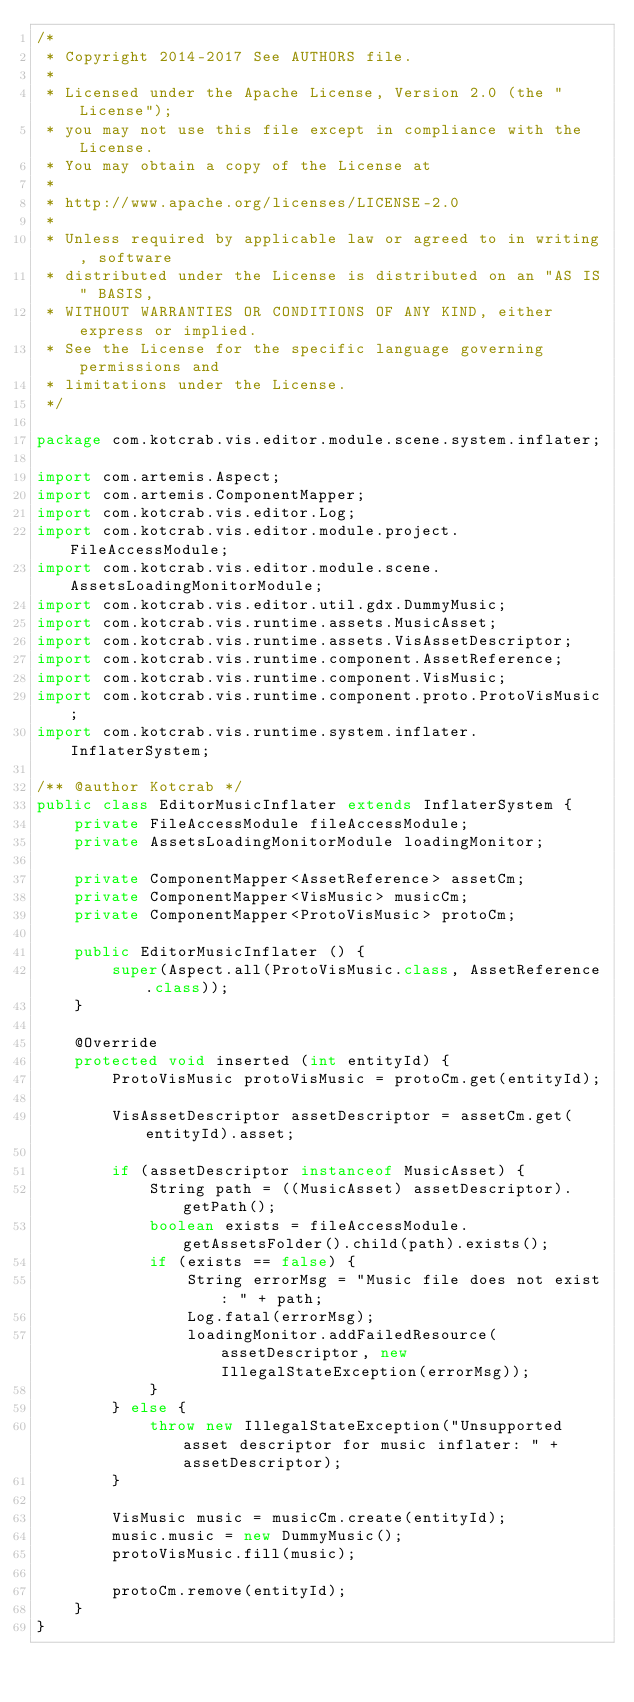<code> <loc_0><loc_0><loc_500><loc_500><_Java_>/*
 * Copyright 2014-2017 See AUTHORS file.
 *
 * Licensed under the Apache License, Version 2.0 (the "License");
 * you may not use this file except in compliance with the License.
 * You may obtain a copy of the License at
 *
 * http://www.apache.org/licenses/LICENSE-2.0
 *
 * Unless required by applicable law or agreed to in writing, software
 * distributed under the License is distributed on an "AS IS" BASIS,
 * WITHOUT WARRANTIES OR CONDITIONS OF ANY KIND, either express or implied.
 * See the License for the specific language governing permissions and
 * limitations under the License.
 */

package com.kotcrab.vis.editor.module.scene.system.inflater;

import com.artemis.Aspect;
import com.artemis.ComponentMapper;
import com.kotcrab.vis.editor.Log;
import com.kotcrab.vis.editor.module.project.FileAccessModule;
import com.kotcrab.vis.editor.module.scene.AssetsLoadingMonitorModule;
import com.kotcrab.vis.editor.util.gdx.DummyMusic;
import com.kotcrab.vis.runtime.assets.MusicAsset;
import com.kotcrab.vis.runtime.assets.VisAssetDescriptor;
import com.kotcrab.vis.runtime.component.AssetReference;
import com.kotcrab.vis.runtime.component.VisMusic;
import com.kotcrab.vis.runtime.component.proto.ProtoVisMusic;
import com.kotcrab.vis.runtime.system.inflater.InflaterSystem;

/** @author Kotcrab */
public class EditorMusicInflater extends InflaterSystem {
	private FileAccessModule fileAccessModule;
	private AssetsLoadingMonitorModule loadingMonitor;

	private ComponentMapper<AssetReference> assetCm;
	private ComponentMapper<VisMusic> musicCm;
	private ComponentMapper<ProtoVisMusic> protoCm;

	public EditorMusicInflater () {
		super(Aspect.all(ProtoVisMusic.class, AssetReference.class));
	}

	@Override
	protected void inserted (int entityId) {
		ProtoVisMusic protoVisMusic = protoCm.get(entityId);

		VisAssetDescriptor assetDescriptor = assetCm.get(entityId).asset;

		if (assetDescriptor instanceof MusicAsset) {
			String path = ((MusicAsset) assetDescriptor).getPath();
			boolean exists = fileAccessModule.getAssetsFolder().child(path).exists();
			if (exists == false) {
				String errorMsg = "Music file does not exist: " + path;
				Log.fatal(errorMsg);
				loadingMonitor.addFailedResource(assetDescriptor, new IllegalStateException(errorMsg));
			}
		} else {
			throw new IllegalStateException("Unsupported asset descriptor for music inflater: " + assetDescriptor);
		}

		VisMusic music = musicCm.create(entityId);
		music.music = new DummyMusic();
		protoVisMusic.fill(music);

		protoCm.remove(entityId);
	}
}
</code> 